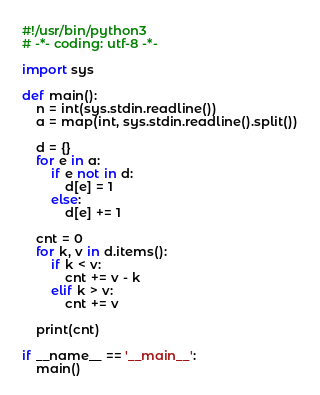<code> <loc_0><loc_0><loc_500><loc_500><_Python_>#!/usr/bin/python3
# -*- coding: utf-8 -*-

import sys

def main():
    n = int(sys.stdin.readline())
    a = map(int, sys.stdin.readline().split())

    d = {}
    for e in a:
        if e not in d:
            d[e] = 1
        else:
            d[e] += 1

    cnt = 0
    for k, v in d.items():
        if k < v:
            cnt += v - k
        elif k > v:
            cnt += v

    print(cnt)

if __name__ == '__main__':
    main()
</code> 